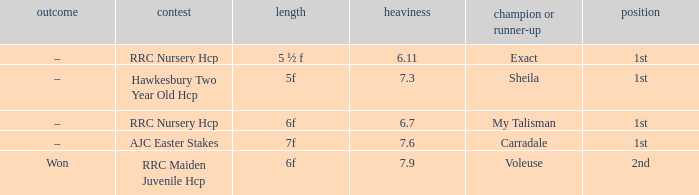What is the largest weight wth a Result of –, and a Distance of 7f? 7.6. 